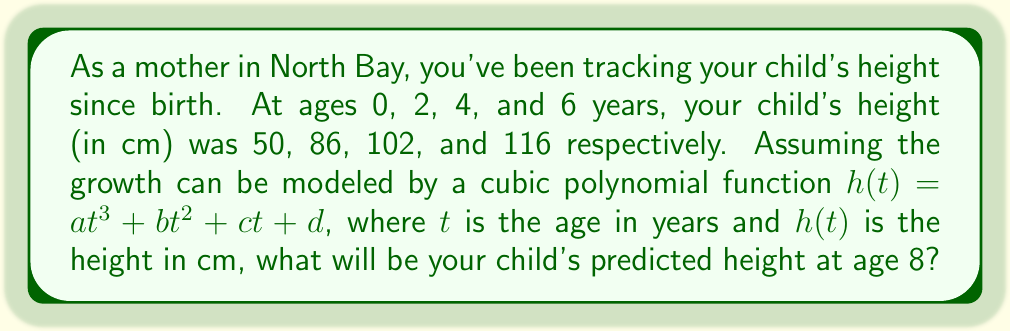Give your solution to this math problem. Let's solve this step-by-step:

1) We have four data points: (0, 50), (2, 86), (4, 102), and (6, 116).

2) We need to find $a$, $b$, $c$, and $d$ in the equation $h(t) = at^3 + bt^2 + ct + d$.

3) Substituting our data points into this equation:

   50 = a(0)^3 + b(0)^2 + c(0) + d
   86 = a(2)^3 + b(2)^2 + c(2) + d
   102 = a(4)^3 + b(4)^2 + c(4) + d
   116 = a(6)^3 + b(6)^2 + c(6) + d

4) Simplifying:

   50 = d
   86 = 8a + 4b + 2c + 50
   102 = 64a + 16b + 4c + 50
   116 = 216a + 36b + 6c + 50

5) Subtracting the first equation from the others:

   36 = 8a + 4b + 2c
   52 = 64a + 16b + 4c
   66 = 216a + 36b + 6c

6) Solving this system of equations (using a computer algebra system or matrix methods), we get:

   a = -0.25
   b = 3
   c = 18
   d = 50

7) Therefore, our function is:

   $h(t) = -0.25t^3 + 3t^2 + 18t + 50$

8) To predict the height at age 8, we substitute t = 8:

   $h(8) = -0.25(8)^3 + 3(8)^2 + 18(8) + 50$
         $= -128 + 192 + 144 + 50$
         $= 258$

Therefore, the predicted height at age 8 is 258 cm.
Answer: 258 cm 